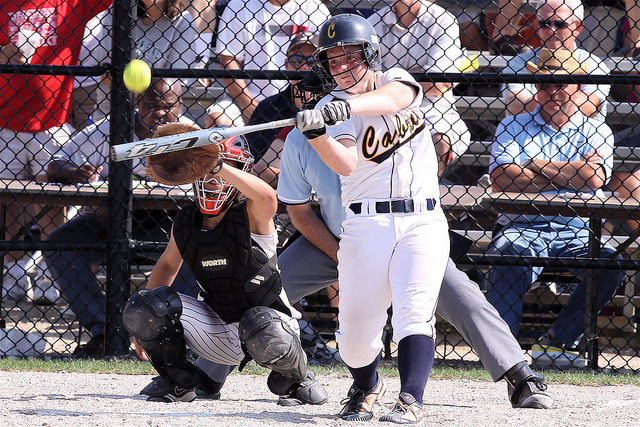If this game had an unexpected magical twist, what do you think it would be? Imagine if suddenly, the bat the player is using starts to glow with a mystical light, and as she swings, time slows down, giving her a supernatural advantage to hit a home run. The ball, when hit, leaves a trail of sparkling stars and the crowd watches in awe as it sails through the air, far beyond the boundaries of the field, suggesting that something extraordinary and magical has taken place. 